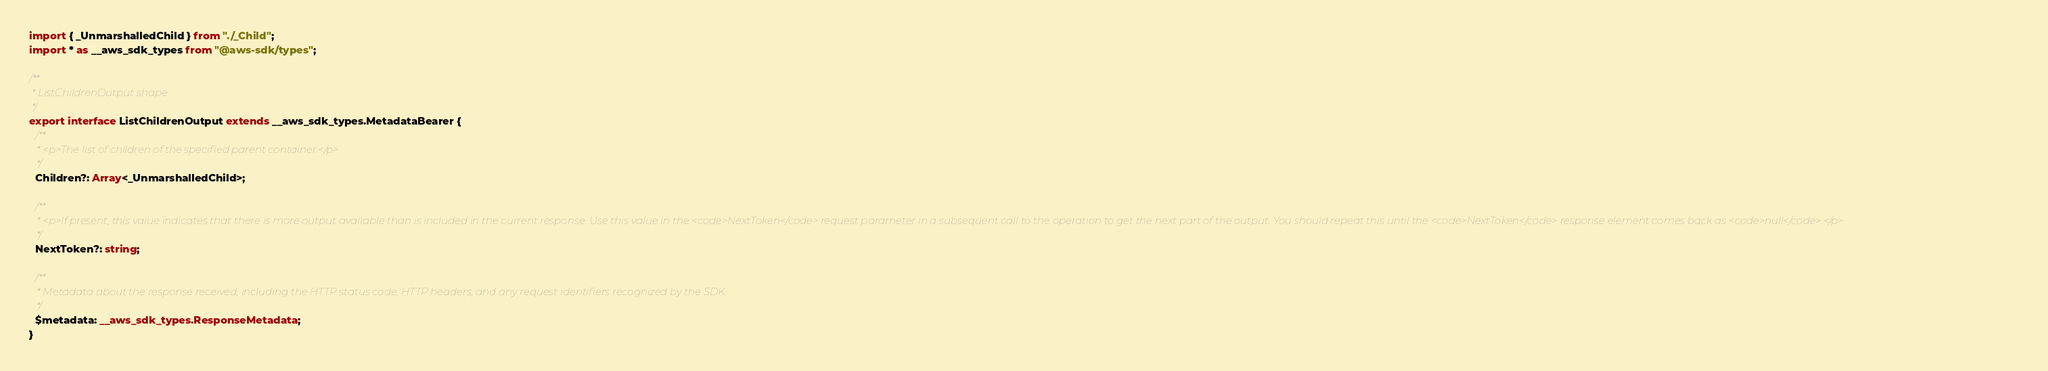<code> <loc_0><loc_0><loc_500><loc_500><_TypeScript_>import { _UnmarshalledChild } from "./_Child";
import * as __aws_sdk_types from "@aws-sdk/types";

/**
 * ListChildrenOutput shape
 */
export interface ListChildrenOutput extends __aws_sdk_types.MetadataBearer {
  /**
   * <p>The list of children of the specified parent container.</p>
   */
  Children?: Array<_UnmarshalledChild>;

  /**
   * <p>If present, this value indicates that there is more output available than is included in the current response. Use this value in the <code>NextToken</code> request parameter in a subsequent call to the operation to get the next part of the output. You should repeat this until the <code>NextToken</code> response element comes back as <code>null</code>.</p>
   */
  NextToken?: string;

  /**
   * Metadata about the response received, including the HTTP status code, HTTP headers, and any request identifiers recognized by the SDK.
   */
  $metadata: __aws_sdk_types.ResponseMetadata;
}
</code> 